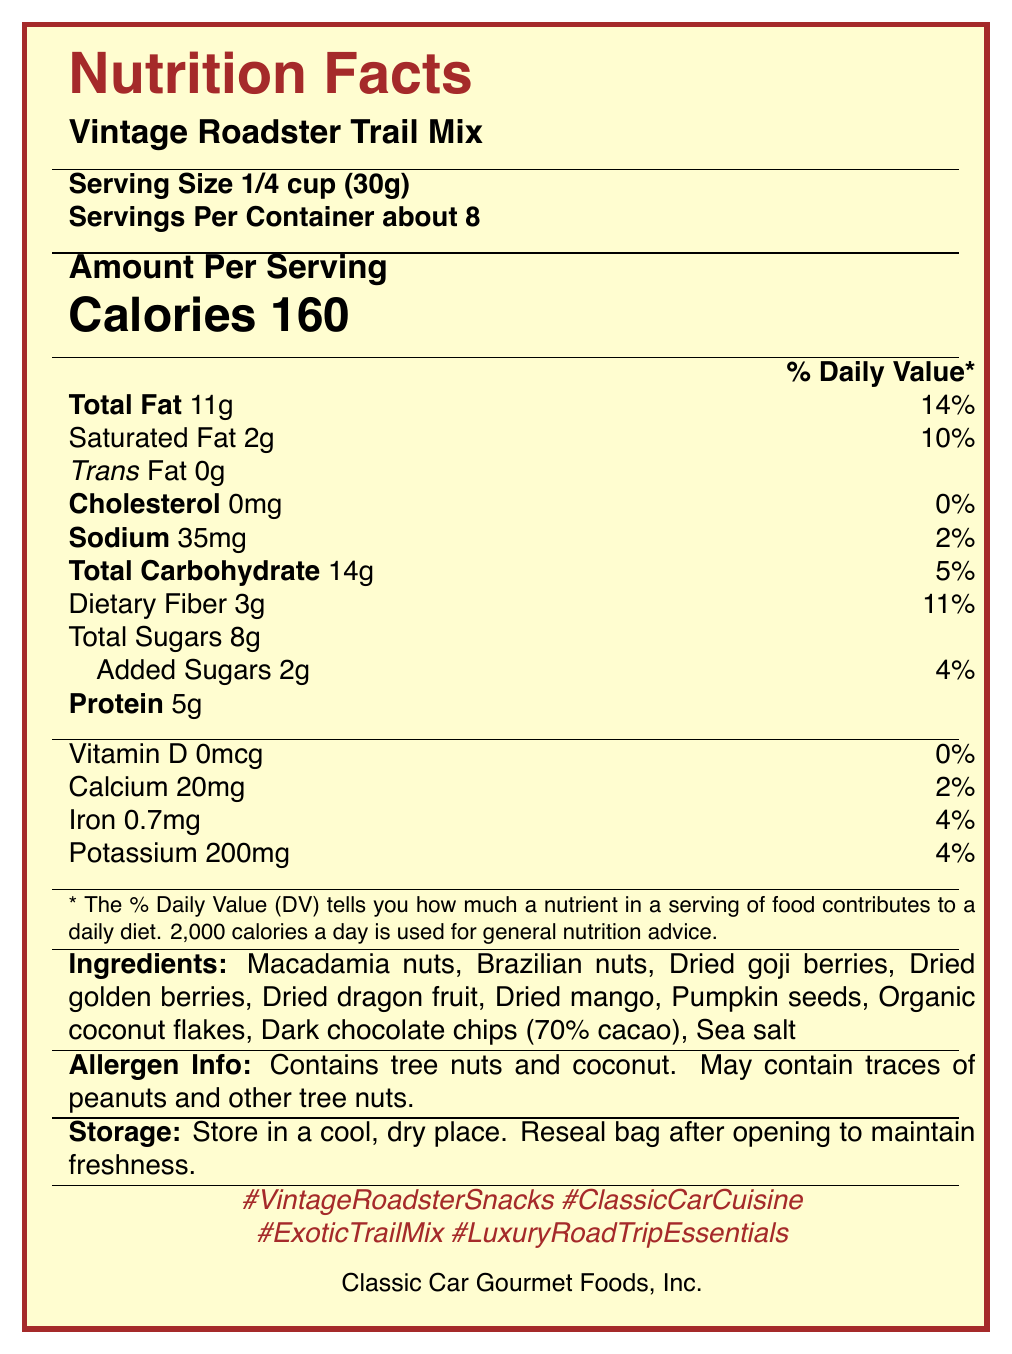what is the serving size of the Vintage Roadster Trail Mix? The serving size is mentioned as "1/4 cup (30g)" in the Nutrition Facts.
Answer: 1/4 cup (30g) how many calories are in one serving of the snack mix? The document states "Calories 160" in the Nutrition Facts section.
Answer: 160 what amount of total fat does one serving contain? The serving size contains 11g of total fat as indicated in the Nutrition Facts.
Answer: 11g how many servings per container are there? The label mentions "Servings Per Container about 8".
Answer: about 8 what is the amount of added sugars in one serving? The document lists "Added Sugars 2g" under Total Sugars in the Nutrition Facts.
Answer: 2g what are the primary ingredients in the Vintage Roadster Trail Mix? The ingredients are specifically listed towards the bottom of the Nutrition Facts document.
Answer: Macadamia nuts, Brazilian nuts, Dried goji berries, Dried golden berries, Dried dragon fruit, Dried mango, Pumpkin seeds, Organic coconut flakes, Dark chocolate chips (70% cacao), Sea salt what hashtags are suggested for social media sharing? The hashtags are mentioned at the end of the document: #VintageRoadsterSnacks, #ClassicCarCuisine, #ExoticTrailMix, #LuxuryRoadTripEssentials.
Answer: #VintageRoadsterSnacks, #ClassicCarCuisine, #ExoticTrailMix, #LuxuryRoadTripEssentials how much dietary fiber is in one serving? The nutritional information indicates "Dietary Fiber 3g".
Answer: 3g describe the allergen information given for this product. The allergen info section notes that the product "Contains tree nuts and coconut" and "May contain traces of peanuts and other tree nuts."
Answer: Contains tree nuts and coconut. May contain traces of peanuts and other tree nuts. what is the name of the manufacturer? The manufacturer's name is provided at the bottom of the document: Classic Car Gourmet Foods, Inc.
Answer: Classic Car Gourmet Foods, Inc. what storage instructions are given? The storage instructions in the document advise to "Store in a cool, dry place. Reseal bag after opening to maintain freshness."
Answer: Store in a cool, dry place. Reseal bag after opening to maintain freshness. how much protein does one serving of the trail mix contain? The Nutrition Facts state one serving contains 5g of protein.
Answer: 5g which of the following statements is true? A. The product contains 4g of trans fat. B. The product contains 2g of saturated fat. C. The product is manufactured by Roadsters, Inc. The document specifies 2g of saturated fat, with no trans fat, and the manufacturer is Classic Car Gourmet Foods, Inc., not Roadsters, Inc.
Answer: B. The product contains 2g of saturated fat. how many grams of total carbohydrate does a serving of the snack mix contain? A. 14g B. 10g C. 20g D. 35g According to the document, "Total Carbohydrate 14g" per serving.
Answer: A. 14g does the trail mix contain any cholesterol? The document indicates "Cholesterol 0mg".
Answer: No summarize the main idea of the document. The summary highlights key elements of the document, offering an overall understanding of the nutritional facts and additional product details.
Answer: This document provides nutritional information for Vintage Roadster Trail Mix, a gourmet road trip snack mix featuring exotic nuts and dried fruits. It details serving size, calorie content, macronutrient values, vitamins, and minerals. It also includes ingredients, allergen information, storage instructions, and suggested social media hashtags. The product is manufactured by Classic Car Gourmet Foods, Inc. is the price of the Vintage Roadster Trail Mix provided in the document? The document does not contain any information regarding the price of the product.
Answer: Not enough information 